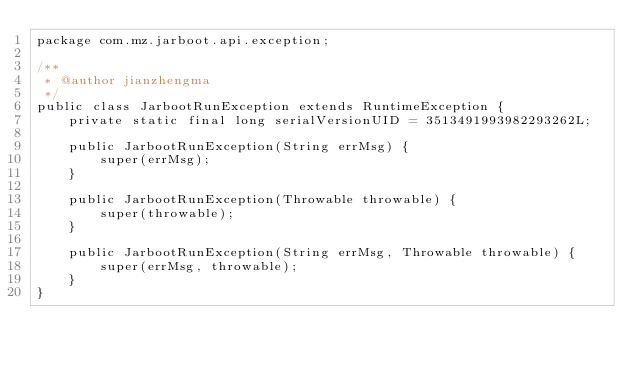Convert code to text. <code><loc_0><loc_0><loc_500><loc_500><_Java_>package com.mz.jarboot.api.exception;

/**
 * @author jianzhengma
 */
public class JarbootRunException extends RuntimeException {
    private static final long serialVersionUID = 3513491993982293262L;

    public JarbootRunException(String errMsg) {
        super(errMsg);
    }

    public JarbootRunException(Throwable throwable) {
        super(throwable);
    }

    public JarbootRunException(String errMsg, Throwable throwable) {
        super(errMsg, throwable);
    }
}
</code> 